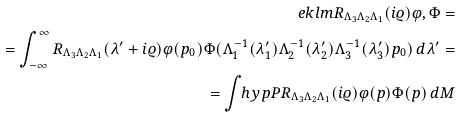Convert formula to latex. <formula><loc_0><loc_0><loc_500><loc_500>\ e k l m { R _ { \Lambda _ { 3 } \Lambda _ { 2 } \Lambda _ { 1 } } ( i \varrho ) \varphi , \Phi } = \\ = \int ^ { \infty } _ { - \infty } R _ { \Lambda _ { 3 } \Lambda _ { 2 } \Lambda _ { 1 } } ( \lambda ^ { \prime } + i \varrho ) \varphi ( p _ { 0 } ) \Phi ( \Lambda _ { 1 } ^ { - 1 } ( \lambda _ { 1 } ^ { \prime } ) \Lambda _ { 2 } ^ { - 1 } ( \lambda _ { 2 } ^ { \prime } ) \Lambda _ { 3 } ^ { - 1 } ( \lambda _ { 3 } ^ { \prime } ) p _ { 0 } ) \, d \lambda ^ { \prime } = \\ = \int _ { \ } h y p P R _ { \Lambda _ { 3 } \Lambda _ { 2 } \Lambda _ { 1 } } ( i \varrho ) \varphi ( p ) \Phi ( p ) \, d M</formula> 